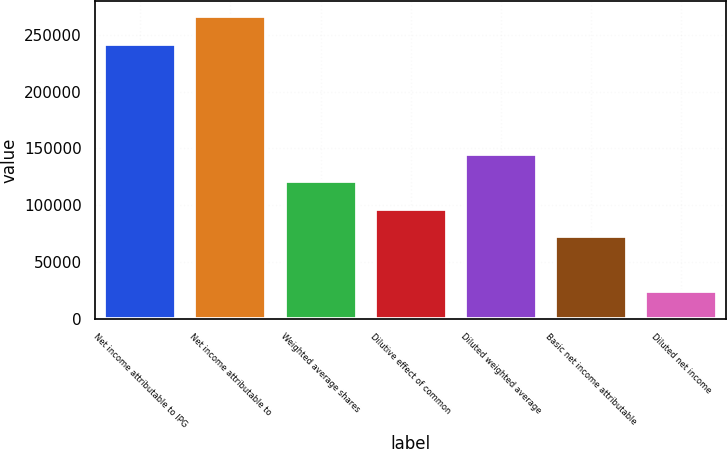Convert chart to OTSL. <chart><loc_0><loc_0><loc_500><loc_500><bar_chart><fcel>Net income attributable to IPG<fcel>Net income attributable to<fcel>Weighted average shares<fcel>Dilutive effect of common<fcel>Diluted weighted average<fcel>Basic net income attributable<fcel>Diluted net income<nl><fcel>242154<fcel>266369<fcel>121079<fcel>96864.3<fcel>145294<fcel>72649.4<fcel>24219.5<nl></chart> 